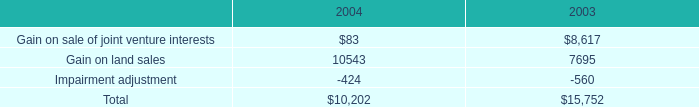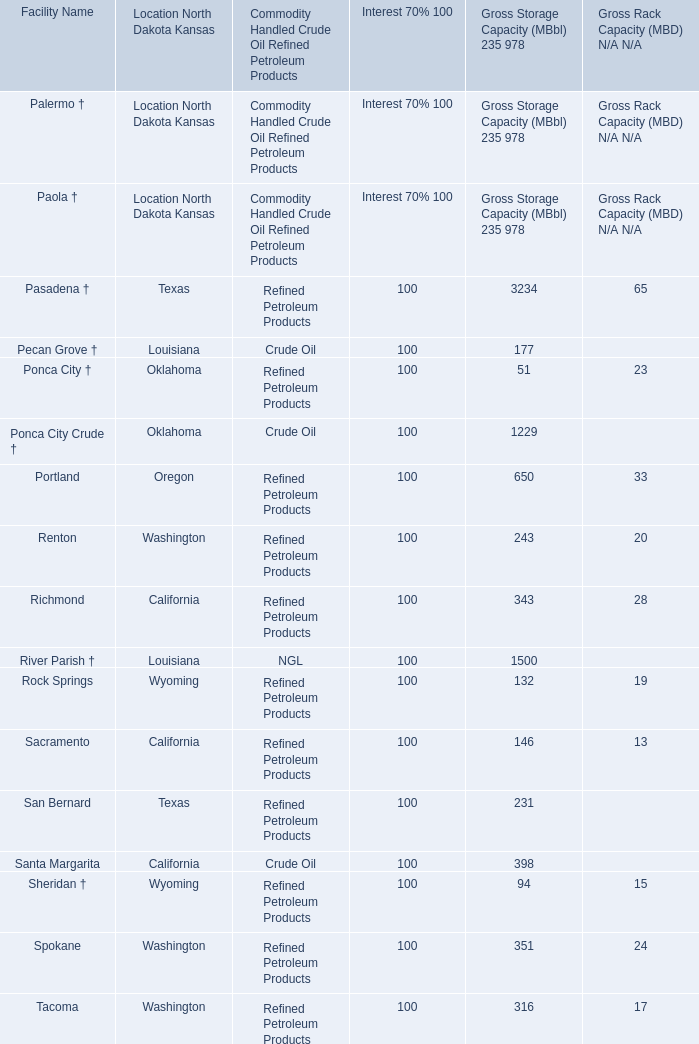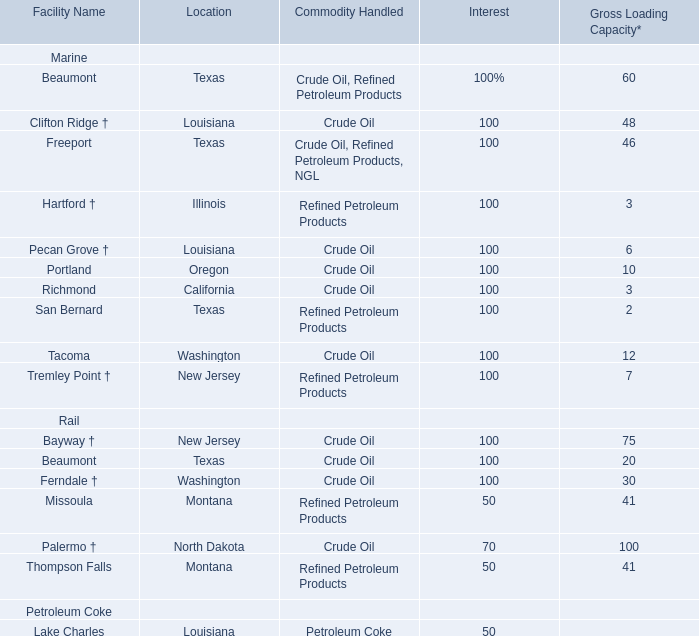As As the chart 1 shows,what is the Gross Storage Capacity for Facility Sacramento in California in terms of Refined Petroleum Products? (in MBbl) 
Answer: 146. 